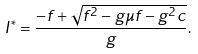<formula> <loc_0><loc_0><loc_500><loc_500>I ^ { * } = \frac { - f + \sqrt { f ^ { 2 } - g \mu f - g ^ { 2 } c } } { g } .</formula> 